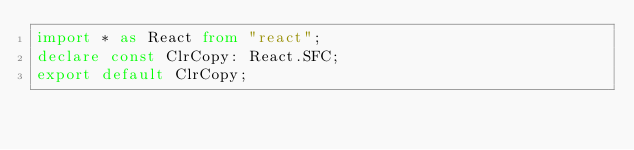<code> <loc_0><loc_0><loc_500><loc_500><_TypeScript_>import * as React from "react";
declare const ClrCopy: React.SFC;
export default ClrCopy;
</code> 